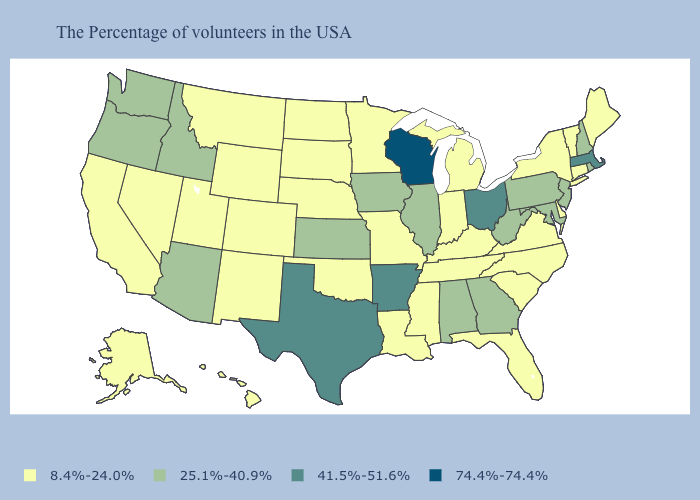What is the lowest value in the USA?
Write a very short answer. 8.4%-24.0%. Which states have the highest value in the USA?
Answer briefly. Wisconsin. Name the states that have a value in the range 8.4%-24.0%?
Give a very brief answer. Maine, Vermont, Connecticut, New York, Delaware, Virginia, North Carolina, South Carolina, Florida, Michigan, Kentucky, Indiana, Tennessee, Mississippi, Louisiana, Missouri, Minnesota, Nebraska, Oklahoma, South Dakota, North Dakota, Wyoming, Colorado, New Mexico, Utah, Montana, Nevada, California, Alaska, Hawaii. Which states have the lowest value in the USA?
Give a very brief answer. Maine, Vermont, Connecticut, New York, Delaware, Virginia, North Carolina, South Carolina, Florida, Michigan, Kentucky, Indiana, Tennessee, Mississippi, Louisiana, Missouri, Minnesota, Nebraska, Oklahoma, South Dakota, North Dakota, Wyoming, Colorado, New Mexico, Utah, Montana, Nevada, California, Alaska, Hawaii. How many symbols are there in the legend?
Short answer required. 4. Name the states that have a value in the range 41.5%-51.6%?
Write a very short answer. Massachusetts, Ohio, Arkansas, Texas. Name the states that have a value in the range 74.4%-74.4%?
Answer briefly. Wisconsin. What is the highest value in the West ?
Write a very short answer. 25.1%-40.9%. Among the states that border New Mexico , which have the highest value?
Short answer required. Texas. Name the states that have a value in the range 25.1%-40.9%?
Concise answer only. Rhode Island, New Hampshire, New Jersey, Maryland, Pennsylvania, West Virginia, Georgia, Alabama, Illinois, Iowa, Kansas, Arizona, Idaho, Washington, Oregon. Does Massachusetts have the highest value in the Northeast?
Short answer required. Yes. Does Maine have a lower value than Virginia?
Keep it brief. No. What is the value of California?
Be succinct. 8.4%-24.0%. Does Idaho have the lowest value in the USA?
Keep it brief. No. Name the states that have a value in the range 8.4%-24.0%?
Short answer required. Maine, Vermont, Connecticut, New York, Delaware, Virginia, North Carolina, South Carolina, Florida, Michigan, Kentucky, Indiana, Tennessee, Mississippi, Louisiana, Missouri, Minnesota, Nebraska, Oklahoma, South Dakota, North Dakota, Wyoming, Colorado, New Mexico, Utah, Montana, Nevada, California, Alaska, Hawaii. 